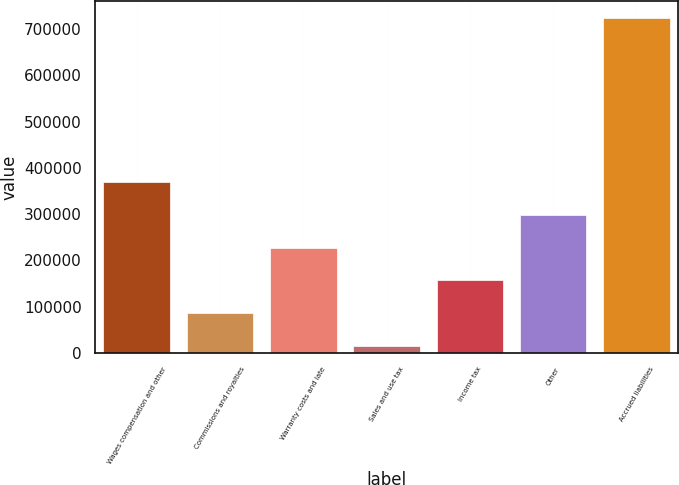<chart> <loc_0><loc_0><loc_500><loc_500><bar_chart><fcel>Wages compensation and other<fcel>Commissions and royalties<fcel>Warranty costs and late<fcel>Sales and use tax<fcel>Income tax<fcel>Other<fcel>Accrued liabilities<nl><fcel>369513<fcel>85766.6<fcel>227640<fcel>14830<fcel>156703<fcel>298576<fcel>724196<nl></chart> 